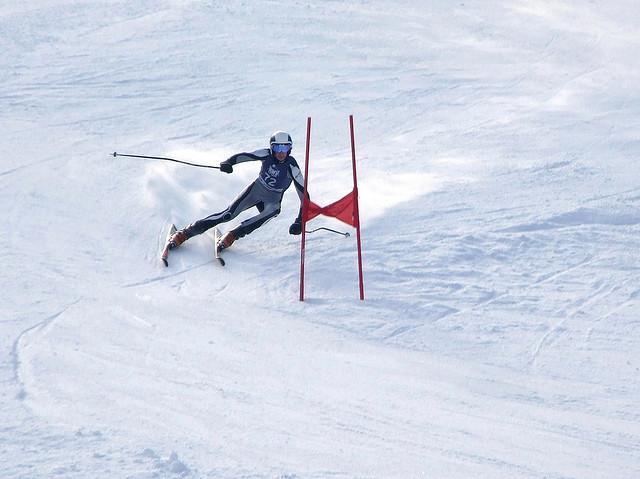How many people are on the snow?
Give a very brief answer. 1. How many train cars are orange?
Give a very brief answer. 0. 